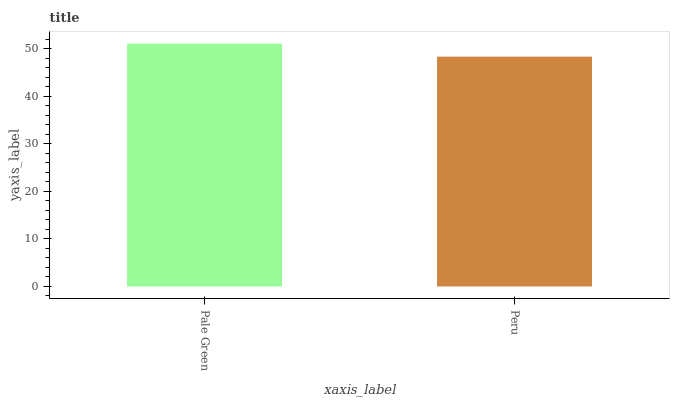Is Peru the minimum?
Answer yes or no. Yes. Is Pale Green the maximum?
Answer yes or no. Yes. Is Peru the maximum?
Answer yes or no. No. Is Pale Green greater than Peru?
Answer yes or no. Yes. Is Peru less than Pale Green?
Answer yes or no. Yes. Is Peru greater than Pale Green?
Answer yes or no. No. Is Pale Green less than Peru?
Answer yes or no. No. Is Pale Green the high median?
Answer yes or no. Yes. Is Peru the low median?
Answer yes or no. Yes. Is Peru the high median?
Answer yes or no. No. Is Pale Green the low median?
Answer yes or no. No. 